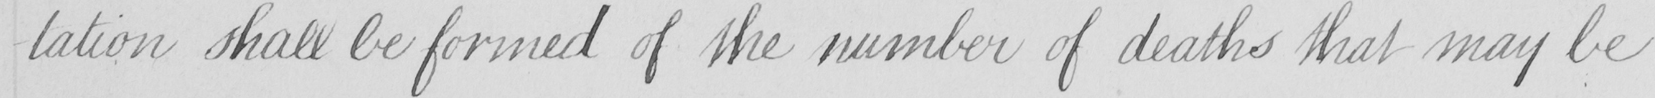What is written in this line of handwriting? -tation shall be formed of the number of deaths that may be 